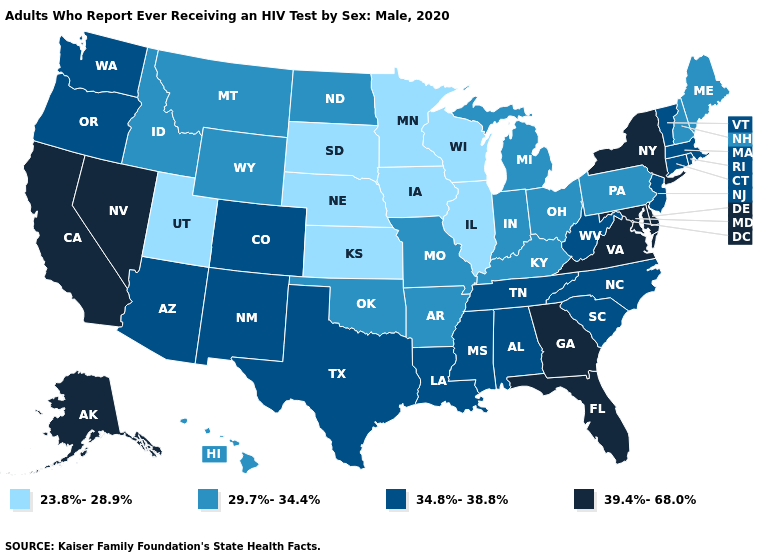Which states have the lowest value in the West?
Answer briefly. Utah. What is the value of Iowa?
Write a very short answer. 23.8%-28.9%. Does the first symbol in the legend represent the smallest category?
Write a very short answer. Yes. Name the states that have a value in the range 34.8%-38.8%?
Give a very brief answer. Alabama, Arizona, Colorado, Connecticut, Louisiana, Massachusetts, Mississippi, New Jersey, New Mexico, North Carolina, Oregon, Rhode Island, South Carolina, Tennessee, Texas, Vermont, Washington, West Virginia. What is the lowest value in states that border Rhode Island?
Give a very brief answer. 34.8%-38.8%. Does Washington have a lower value than Maryland?
Write a very short answer. Yes. Name the states that have a value in the range 23.8%-28.9%?
Give a very brief answer. Illinois, Iowa, Kansas, Minnesota, Nebraska, South Dakota, Utah, Wisconsin. Which states have the lowest value in the USA?
Answer briefly. Illinois, Iowa, Kansas, Minnesota, Nebraska, South Dakota, Utah, Wisconsin. Which states have the highest value in the USA?
Quick response, please. Alaska, California, Delaware, Florida, Georgia, Maryland, Nevada, New York, Virginia. Does the first symbol in the legend represent the smallest category?
Write a very short answer. Yes. Name the states that have a value in the range 39.4%-68.0%?
Quick response, please. Alaska, California, Delaware, Florida, Georgia, Maryland, Nevada, New York, Virginia. Among the states that border Iowa , does Missouri have the highest value?
Write a very short answer. Yes. What is the highest value in the MidWest ?
Keep it brief. 29.7%-34.4%. Among the states that border Ohio , does Pennsylvania have the highest value?
Write a very short answer. No. Name the states that have a value in the range 23.8%-28.9%?
Keep it brief. Illinois, Iowa, Kansas, Minnesota, Nebraska, South Dakota, Utah, Wisconsin. 